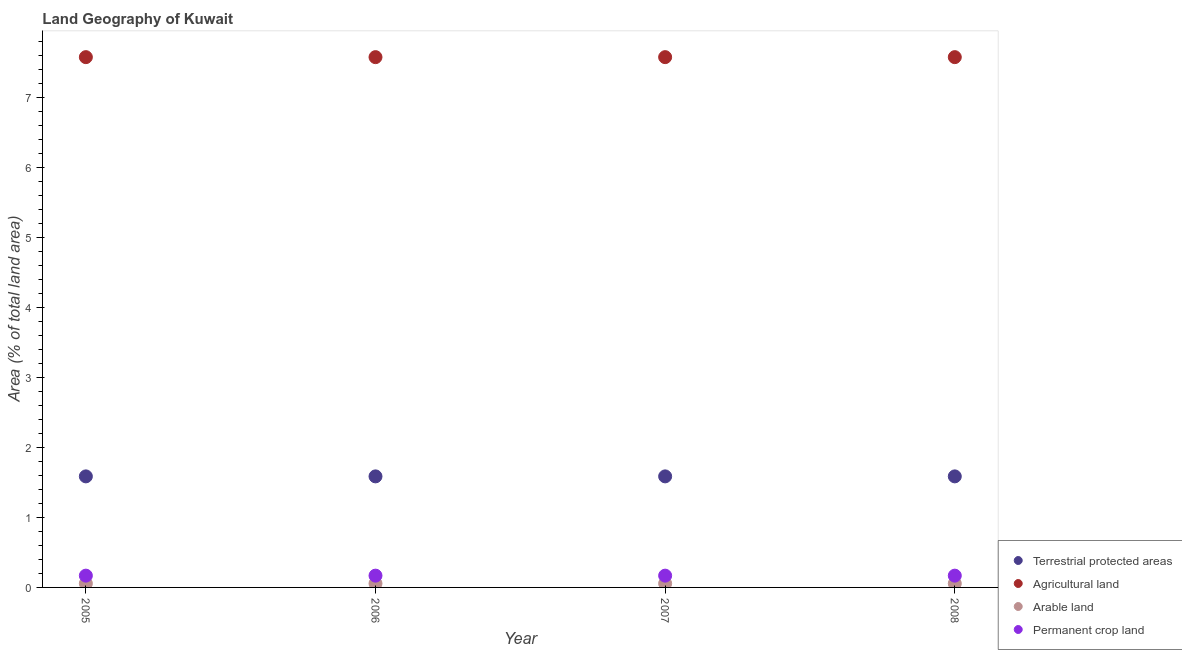Is the number of dotlines equal to the number of legend labels?
Offer a very short reply. Yes. What is the percentage of land under terrestrial protection in 2007?
Ensure brevity in your answer.  1.59. Across all years, what is the maximum percentage of area under agricultural land?
Give a very brief answer. 7.58. Across all years, what is the minimum percentage of land under terrestrial protection?
Give a very brief answer. 1.59. In which year was the percentage of area under arable land maximum?
Your response must be concise. 2005. What is the total percentage of area under agricultural land in the graph?
Provide a succinct answer. 30.3. What is the difference between the percentage of land under terrestrial protection in 2006 and the percentage of area under arable land in 2008?
Offer a very short reply. 1.53. What is the average percentage of area under agricultural land per year?
Provide a succinct answer. 7.58. In the year 2007, what is the difference between the percentage of area under agricultural land and percentage of area under arable land?
Offer a very short reply. 7.52. Is the percentage of area under agricultural land in 2005 less than that in 2007?
Your answer should be compact. No. What is the difference between the highest and the second highest percentage of area under permanent crop land?
Your answer should be compact. 0. What is the difference between the highest and the lowest percentage of land under terrestrial protection?
Your answer should be very brief. 0. In how many years, is the percentage of area under agricultural land greater than the average percentage of area under agricultural land taken over all years?
Give a very brief answer. 0. Is the sum of the percentage of area under agricultural land in 2005 and 2008 greater than the maximum percentage of area under permanent crop land across all years?
Make the answer very short. Yes. Is it the case that in every year, the sum of the percentage of area under permanent crop land and percentage of area under arable land is greater than the sum of percentage of area under agricultural land and percentage of land under terrestrial protection?
Ensure brevity in your answer.  Yes. Is it the case that in every year, the sum of the percentage of land under terrestrial protection and percentage of area under agricultural land is greater than the percentage of area under arable land?
Offer a very short reply. Yes. Does the percentage of area under permanent crop land monotonically increase over the years?
Offer a terse response. No. How many years are there in the graph?
Offer a terse response. 4. Are the values on the major ticks of Y-axis written in scientific E-notation?
Ensure brevity in your answer.  No. How many legend labels are there?
Your answer should be compact. 4. How are the legend labels stacked?
Your answer should be very brief. Vertical. What is the title of the graph?
Your answer should be compact. Land Geography of Kuwait. What is the label or title of the X-axis?
Offer a terse response. Year. What is the label or title of the Y-axis?
Make the answer very short. Area (% of total land area). What is the Area (% of total land area) of Terrestrial protected areas in 2005?
Provide a short and direct response. 1.59. What is the Area (% of total land area) in Agricultural land in 2005?
Offer a terse response. 7.58. What is the Area (% of total land area) of Arable land in 2005?
Give a very brief answer. 0.06. What is the Area (% of total land area) of Permanent crop land in 2005?
Offer a terse response. 0.17. What is the Area (% of total land area) in Terrestrial protected areas in 2006?
Provide a succinct answer. 1.59. What is the Area (% of total land area) in Agricultural land in 2006?
Make the answer very short. 7.58. What is the Area (% of total land area) in Arable land in 2006?
Give a very brief answer. 0.06. What is the Area (% of total land area) in Permanent crop land in 2006?
Offer a very short reply. 0.17. What is the Area (% of total land area) in Terrestrial protected areas in 2007?
Your answer should be compact. 1.59. What is the Area (% of total land area) in Agricultural land in 2007?
Give a very brief answer. 7.58. What is the Area (% of total land area) in Arable land in 2007?
Offer a terse response. 0.06. What is the Area (% of total land area) in Permanent crop land in 2007?
Make the answer very short. 0.17. What is the Area (% of total land area) of Terrestrial protected areas in 2008?
Provide a succinct answer. 1.59. What is the Area (% of total land area) in Agricultural land in 2008?
Ensure brevity in your answer.  7.58. What is the Area (% of total land area) of Arable land in 2008?
Your answer should be very brief. 0.06. What is the Area (% of total land area) in Permanent crop land in 2008?
Provide a succinct answer. 0.17. Across all years, what is the maximum Area (% of total land area) of Terrestrial protected areas?
Make the answer very short. 1.59. Across all years, what is the maximum Area (% of total land area) in Agricultural land?
Offer a very short reply. 7.58. Across all years, what is the maximum Area (% of total land area) in Arable land?
Offer a very short reply. 0.06. Across all years, what is the maximum Area (% of total land area) of Permanent crop land?
Ensure brevity in your answer.  0.17. Across all years, what is the minimum Area (% of total land area) of Terrestrial protected areas?
Offer a terse response. 1.59. Across all years, what is the minimum Area (% of total land area) of Agricultural land?
Provide a short and direct response. 7.58. Across all years, what is the minimum Area (% of total land area) in Arable land?
Make the answer very short. 0.06. Across all years, what is the minimum Area (% of total land area) of Permanent crop land?
Your answer should be very brief. 0.17. What is the total Area (% of total land area) of Terrestrial protected areas in the graph?
Your answer should be compact. 6.35. What is the total Area (% of total land area) in Agricultural land in the graph?
Your response must be concise. 30.3. What is the total Area (% of total land area) of Arable land in the graph?
Ensure brevity in your answer.  0.22. What is the total Area (% of total land area) of Permanent crop land in the graph?
Make the answer very short. 0.67. What is the difference between the Area (% of total land area) in Terrestrial protected areas in 2005 and that in 2006?
Ensure brevity in your answer.  0. What is the difference between the Area (% of total land area) of Agricultural land in 2005 and that in 2006?
Your response must be concise. 0. What is the difference between the Area (% of total land area) in Permanent crop land in 2005 and that in 2006?
Make the answer very short. 0. What is the difference between the Area (% of total land area) of Arable land in 2005 and that in 2007?
Make the answer very short. 0. What is the difference between the Area (% of total land area) of Permanent crop land in 2005 and that in 2007?
Provide a succinct answer. 0. What is the difference between the Area (% of total land area) of Terrestrial protected areas in 2005 and that in 2008?
Keep it short and to the point. 0. What is the difference between the Area (% of total land area) in Arable land in 2005 and that in 2008?
Your response must be concise. 0. What is the difference between the Area (% of total land area) in Agricultural land in 2006 and that in 2007?
Keep it short and to the point. 0. What is the difference between the Area (% of total land area) of Arable land in 2006 and that in 2007?
Your answer should be compact. 0. What is the difference between the Area (% of total land area) of Permanent crop land in 2006 and that in 2007?
Provide a short and direct response. 0. What is the difference between the Area (% of total land area) of Terrestrial protected areas in 2006 and that in 2008?
Offer a very short reply. 0. What is the difference between the Area (% of total land area) of Agricultural land in 2006 and that in 2008?
Your answer should be very brief. 0. What is the difference between the Area (% of total land area) in Arable land in 2006 and that in 2008?
Provide a short and direct response. 0. What is the difference between the Area (% of total land area) of Agricultural land in 2007 and that in 2008?
Keep it short and to the point. 0. What is the difference between the Area (% of total land area) in Permanent crop land in 2007 and that in 2008?
Your answer should be very brief. 0. What is the difference between the Area (% of total land area) in Terrestrial protected areas in 2005 and the Area (% of total land area) in Agricultural land in 2006?
Give a very brief answer. -5.99. What is the difference between the Area (% of total land area) of Terrestrial protected areas in 2005 and the Area (% of total land area) of Arable land in 2006?
Your answer should be very brief. 1.53. What is the difference between the Area (% of total land area) of Terrestrial protected areas in 2005 and the Area (% of total land area) of Permanent crop land in 2006?
Your response must be concise. 1.42. What is the difference between the Area (% of total land area) in Agricultural land in 2005 and the Area (% of total land area) in Arable land in 2006?
Keep it short and to the point. 7.52. What is the difference between the Area (% of total land area) of Agricultural land in 2005 and the Area (% of total land area) of Permanent crop land in 2006?
Offer a terse response. 7.41. What is the difference between the Area (% of total land area) of Arable land in 2005 and the Area (% of total land area) of Permanent crop land in 2006?
Provide a succinct answer. -0.11. What is the difference between the Area (% of total land area) in Terrestrial protected areas in 2005 and the Area (% of total land area) in Agricultural land in 2007?
Your answer should be very brief. -5.99. What is the difference between the Area (% of total land area) of Terrestrial protected areas in 2005 and the Area (% of total land area) of Arable land in 2007?
Offer a terse response. 1.53. What is the difference between the Area (% of total land area) of Terrestrial protected areas in 2005 and the Area (% of total land area) of Permanent crop land in 2007?
Offer a very short reply. 1.42. What is the difference between the Area (% of total land area) in Agricultural land in 2005 and the Area (% of total land area) in Arable land in 2007?
Offer a terse response. 7.52. What is the difference between the Area (% of total land area) of Agricultural land in 2005 and the Area (% of total land area) of Permanent crop land in 2007?
Offer a very short reply. 7.41. What is the difference between the Area (% of total land area) in Arable land in 2005 and the Area (% of total land area) in Permanent crop land in 2007?
Your response must be concise. -0.11. What is the difference between the Area (% of total land area) of Terrestrial protected areas in 2005 and the Area (% of total land area) of Agricultural land in 2008?
Offer a terse response. -5.99. What is the difference between the Area (% of total land area) in Terrestrial protected areas in 2005 and the Area (% of total land area) in Arable land in 2008?
Provide a succinct answer. 1.53. What is the difference between the Area (% of total land area) in Terrestrial protected areas in 2005 and the Area (% of total land area) in Permanent crop land in 2008?
Make the answer very short. 1.42. What is the difference between the Area (% of total land area) in Agricultural land in 2005 and the Area (% of total land area) in Arable land in 2008?
Offer a terse response. 7.52. What is the difference between the Area (% of total land area) in Agricultural land in 2005 and the Area (% of total land area) in Permanent crop land in 2008?
Your answer should be very brief. 7.41. What is the difference between the Area (% of total land area) in Arable land in 2005 and the Area (% of total land area) in Permanent crop land in 2008?
Make the answer very short. -0.11. What is the difference between the Area (% of total land area) of Terrestrial protected areas in 2006 and the Area (% of total land area) of Agricultural land in 2007?
Provide a short and direct response. -5.99. What is the difference between the Area (% of total land area) of Terrestrial protected areas in 2006 and the Area (% of total land area) of Arable land in 2007?
Offer a very short reply. 1.53. What is the difference between the Area (% of total land area) in Terrestrial protected areas in 2006 and the Area (% of total land area) in Permanent crop land in 2007?
Provide a short and direct response. 1.42. What is the difference between the Area (% of total land area) of Agricultural land in 2006 and the Area (% of total land area) of Arable land in 2007?
Make the answer very short. 7.52. What is the difference between the Area (% of total land area) in Agricultural land in 2006 and the Area (% of total land area) in Permanent crop land in 2007?
Make the answer very short. 7.41. What is the difference between the Area (% of total land area) of Arable land in 2006 and the Area (% of total land area) of Permanent crop land in 2007?
Offer a terse response. -0.11. What is the difference between the Area (% of total land area) in Terrestrial protected areas in 2006 and the Area (% of total land area) in Agricultural land in 2008?
Provide a short and direct response. -5.99. What is the difference between the Area (% of total land area) in Terrestrial protected areas in 2006 and the Area (% of total land area) in Arable land in 2008?
Your answer should be very brief. 1.53. What is the difference between the Area (% of total land area) in Terrestrial protected areas in 2006 and the Area (% of total land area) in Permanent crop land in 2008?
Offer a very short reply. 1.42. What is the difference between the Area (% of total land area) in Agricultural land in 2006 and the Area (% of total land area) in Arable land in 2008?
Offer a terse response. 7.52. What is the difference between the Area (% of total land area) in Agricultural land in 2006 and the Area (% of total land area) in Permanent crop land in 2008?
Provide a short and direct response. 7.41. What is the difference between the Area (% of total land area) in Arable land in 2006 and the Area (% of total land area) in Permanent crop land in 2008?
Make the answer very short. -0.11. What is the difference between the Area (% of total land area) in Terrestrial protected areas in 2007 and the Area (% of total land area) in Agricultural land in 2008?
Your response must be concise. -5.99. What is the difference between the Area (% of total land area) in Terrestrial protected areas in 2007 and the Area (% of total land area) in Arable land in 2008?
Give a very brief answer. 1.53. What is the difference between the Area (% of total land area) in Terrestrial protected areas in 2007 and the Area (% of total land area) in Permanent crop land in 2008?
Ensure brevity in your answer.  1.42. What is the difference between the Area (% of total land area) in Agricultural land in 2007 and the Area (% of total land area) in Arable land in 2008?
Provide a succinct answer. 7.52. What is the difference between the Area (% of total land area) in Agricultural land in 2007 and the Area (% of total land area) in Permanent crop land in 2008?
Offer a very short reply. 7.41. What is the difference between the Area (% of total land area) in Arable land in 2007 and the Area (% of total land area) in Permanent crop land in 2008?
Ensure brevity in your answer.  -0.11. What is the average Area (% of total land area) in Terrestrial protected areas per year?
Your response must be concise. 1.59. What is the average Area (% of total land area) in Agricultural land per year?
Make the answer very short. 7.58. What is the average Area (% of total land area) in Arable land per year?
Provide a short and direct response. 0.06. What is the average Area (% of total land area) in Permanent crop land per year?
Give a very brief answer. 0.17. In the year 2005, what is the difference between the Area (% of total land area) in Terrestrial protected areas and Area (% of total land area) in Agricultural land?
Your answer should be compact. -5.99. In the year 2005, what is the difference between the Area (% of total land area) of Terrestrial protected areas and Area (% of total land area) of Arable land?
Offer a terse response. 1.53. In the year 2005, what is the difference between the Area (% of total land area) of Terrestrial protected areas and Area (% of total land area) of Permanent crop land?
Provide a short and direct response. 1.42. In the year 2005, what is the difference between the Area (% of total land area) in Agricultural land and Area (% of total land area) in Arable land?
Offer a very short reply. 7.52. In the year 2005, what is the difference between the Area (% of total land area) of Agricultural land and Area (% of total land area) of Permanent crop land?
Ensure brevity in your answer.  7.41. In the year 2005, what is the difference between the Area (% of total land area) in Arable land and Area (% of total land area) in Permanent crop land?
Provide a succinct answer. -0.11. In the year 2006, what is the difference between the Area (% of total land area) of Terrestrial protected areas and Area (% of total land area) of Agricultural land?
Give a very brief answer. -5.99. In the year 2006, what is the difference between the Area (% of total land area) in Terrestrial protected areas and Area (% of total land area) in Arable land?
Give a very brief answer. 1.53. In the year 2006, what is the difference between the Area (% of total land area) of Terrestrial protected areas and Area (% of total land area) of Permanent crop land?
Offer a very short reply. 1.42. In the year 2006, what is the difference between the Area (% of total land area) in Agricultural land and Area (% of total land area) in Arable land?
Your answer should be compact. 7.52. In the year 2006, what is the difference between the Area (% of total land area) in Agricultural land and Area (% of total land area) in Permanent crop land?
Your answer should be compact. 7.41. In the year 2006, what is the difference between the Area (% of total land area) of Arable land and Area (% of total land area) of Permanent crop land?
Offer a terse response. -0.11. In the year 2007, what is the difference between the Area (% of total land area) in Terrestrial protected areas and Area (% of total land area) in Agricultural land?
Ensure brevity in your answer.  -5.99. In the year 2007, what is the difference between the Area (% of total land area) in Terrestrial protected areas and Area (% of total land area) in Arable land?
Make the answer very short. 1.53. In the year 2007, what is the difference between the Area (% of total land area) in Terrestrial protected areas and Area (% of total land area) in Permanent crop land?
Offer a very short reply. 1.42. In the year 2007, what is the difference between the Area (% of total land area) of Agricultural land and Area (% of total land area) of Arable land?
Provide a succinct answer. 7.52. In the year 2007, what is the difference between the Area (% of total land area) in Agricultural land and Area (% of total land area) in Permanent crop land?
Offer a very short reply. 7.41. In the year 2007, what is the difference between the Area (% of total land area) of Arable land and Area (% of total land area) of Permanent crop land?
Your response must be concise. -0.11. In the year 2008, what is the difference between the Area (% of total land area) of Terrestrial protected areas and Area (% of total land area) of Agricultural land?
Provide a succinct answer. -5.99. In the year 2008, what is the difference between the Area (% of total land area) in Terrestrial protected areas and Area (% of total land area) in Arable land?
Make the answer very short. 1.53. In the year 2008, what is the difference between the Area (% of total land area) in Terrestrial protected areas and Area (% of total land area) in Permanent crop land?
Give a very brief answer. 1.42. In the year 2008, what is the difference between the Area (% of total land area) in Agricultural land and Area (% of total land area) in Arable land?
Provide a succinct answer. 7.52. In the year 2008, what is the difference between the Area (% of total land area) of Agricultural land and Area (% of total land area) of Permanent crop land?
Give a very brief answer. 7.41. In the year 2008, what is the difference between the Area (% of total land area) in Arable land and Area (% of total land area) in Permanent crop land?
Your answer should be very brief. -0.11. What is the ratio of the Area (% of total land area) in Terrestrial protected areas in 2005 to that in 2006?
Your answer should be very brief. 1. What is the ratio of the Area (% of total land area) in Agricultural land in 2005 to that in 2006?
Offer a very short reply. 1. What is the ratio of the Area (% of total land area) in Arable land in 2005 to that in 2006?
Offer a very short reply. 1. What is the ratio of the Area (% of total land area) in Terrestrial protected areas in 2005 to that in 2007?
Your response must be concise. 1. What is the ratio of the Area (% of total land area) in Terrestrial protected areas in 2005 to that in 2008?
Offer a terse response. 1. What is the ratio of the Area (% of total land area) in Agricultural land in 2005 to that in 2008?
Make the answer very short. 1. What is the ratio of the Area (% of total land area) of Agricultural land in 2006 to that in 2007?
Your answer should be very brief. 1. What is the ratio of the Area (% of total land area) in Arable land in 2006 to that in 2007?
Offer a very short reply. 1. What is the ratio of the Area (% of total land area) of Permanent crop land in 2006 to that in 2007?
Provide a short and direct response. 1. What is the ratio of the Area (% of total land area) in Terrestrial protected areas in 2006 to that in 2008?
Make the answer very short. 1. What is the ratio of the Area (% of total land area) in Arable land in 2006 to that in 2008?
Ensure brevity in your answer.  1. What is the ratio of the Area (% of total land area) in Permanent crop land in 2006 to that in 2008?
Ensure brevity in your answer.  1. What is the ratio of the Area (% of total land area) of Agricultural land in 2007 to that in 2008?
Make the answer very short. 1. What is the difference between the highest and the second highest Area (% of total land area) of Terrestrial protected areas?
Your response must be concise. 0. What is the difference between the highest and the second highest Area (% of total land area) in Agricultural land?
Offer a very short reply. 0. What is the difference between the highest and the second highest Area (% of total land area) in Arable land?
Offer a very short reply. 0. What is the difference between the highest and the second highest Area (% of total land area) of Permanent crop land?
Provide a succinct answer. 0. What is the difference between the highest and the lowest Area (% of total land area) in Terrestrial protected areas?
Your answer should be compact. 0. What is the difference between the highest and the lowest Area (% of total land area) in Agricultural land?
Your answer should be compact. 0. 